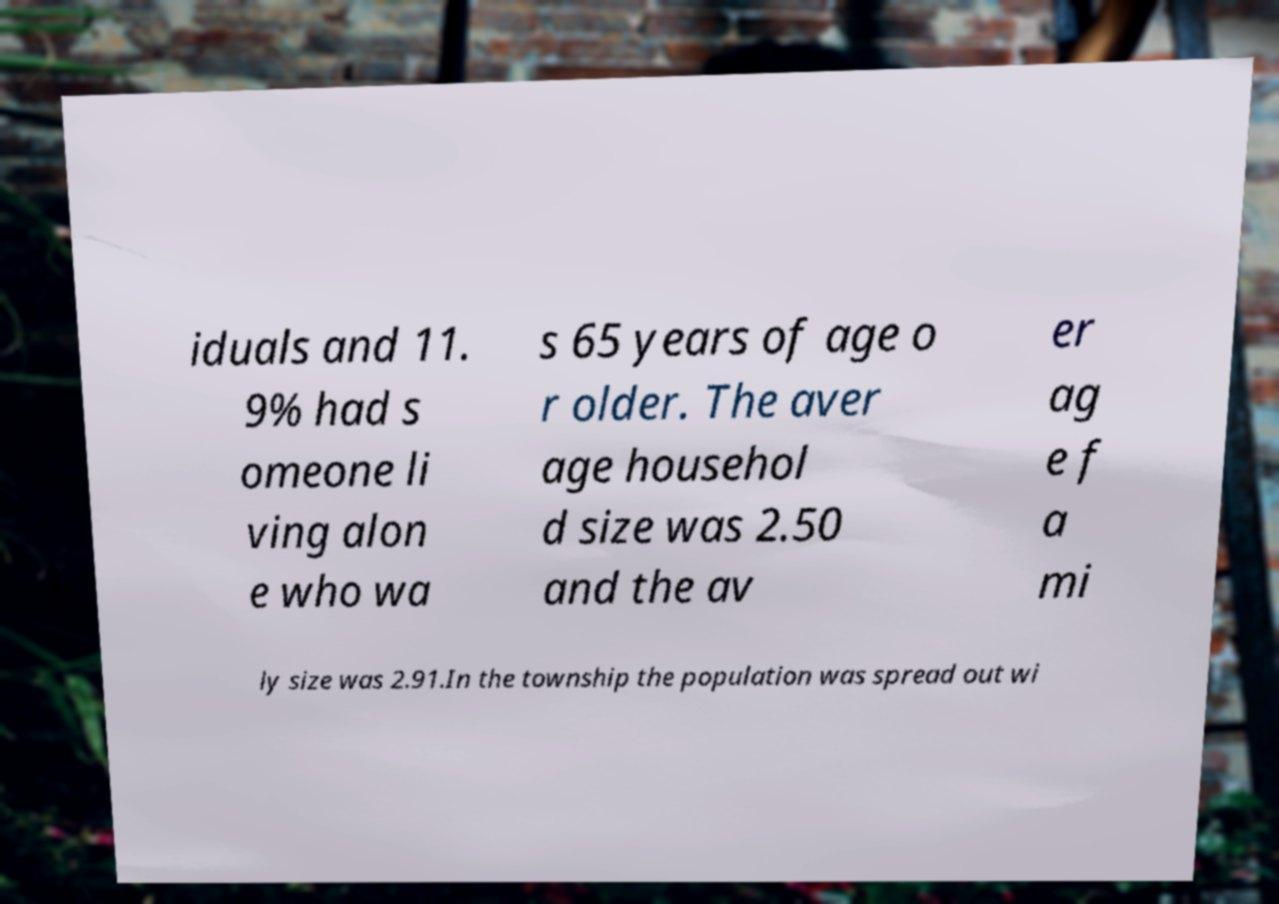Please identify and transcribe the text found in this image. iduals and 11. 9% had s omeone li ving alon e who wa s 65 years of age o r older. The aver age househol d size was 2.50 and the av er ag e f a mi ly size was 2.91.In the township the population was spread out wi 